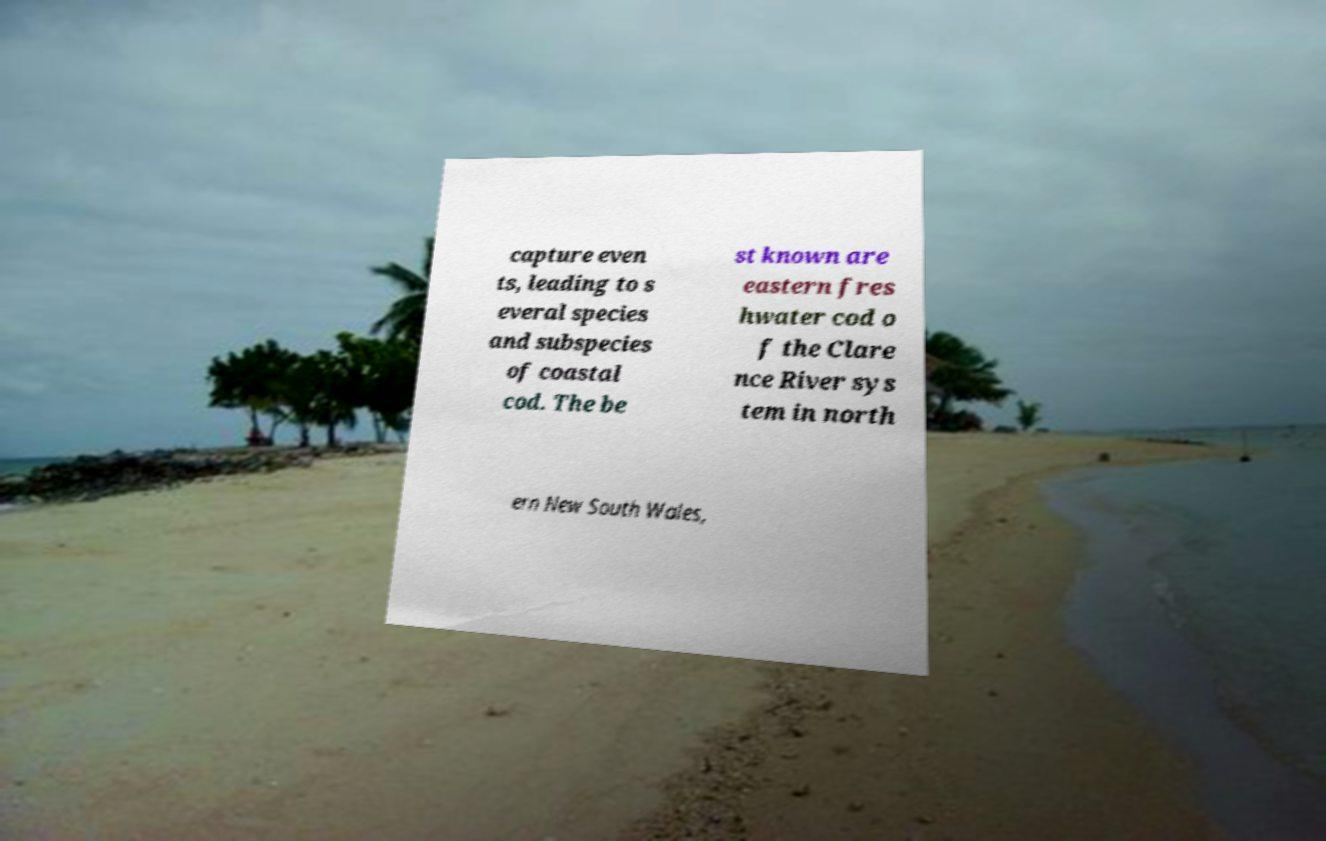What messages or text are displayed in this image? I need them in a readable, typed format. capture even ts, leading to s everal species and subspecies of coastal cod. The be st known are eastern fres hwater cod o f the Clare nce River sys tem in north ern New South Wales, 